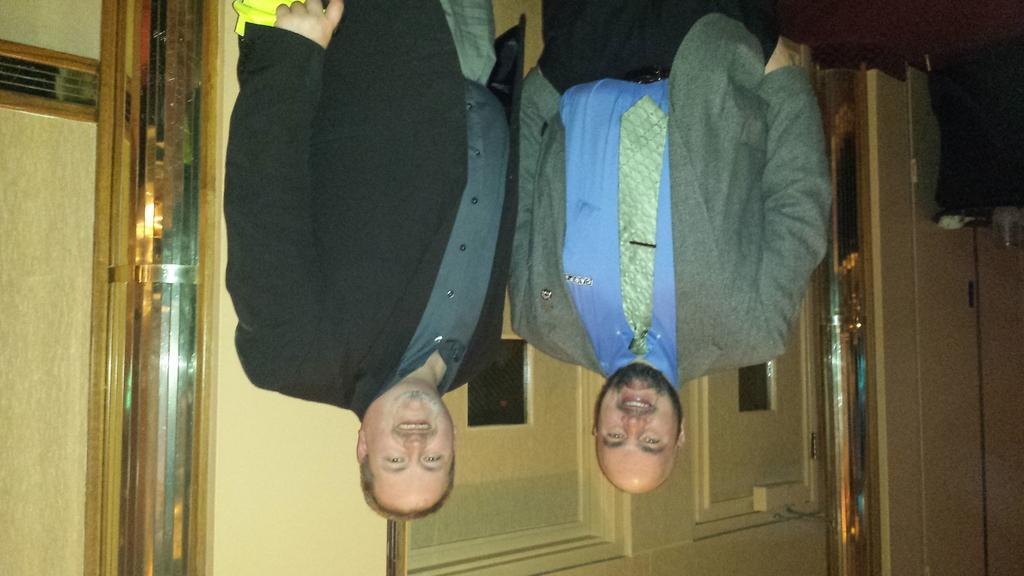Could you give a brief overview of what you see in this image? There are two persons standing in the middle of this image and there is a wall at the bottom of this image. 